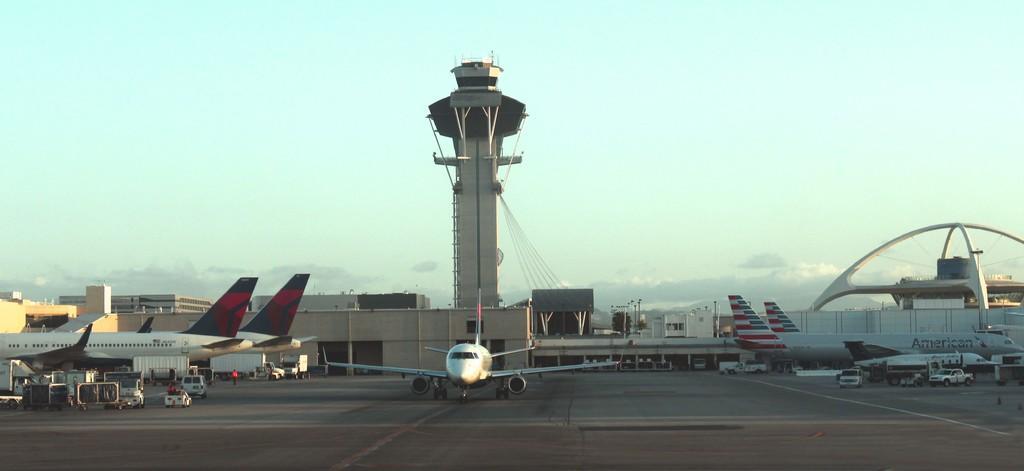Please provide a concise description of this image. In this picture we can see buildings, tower, arches, planes, vehicles, people, cloudy sky, poles and things.   